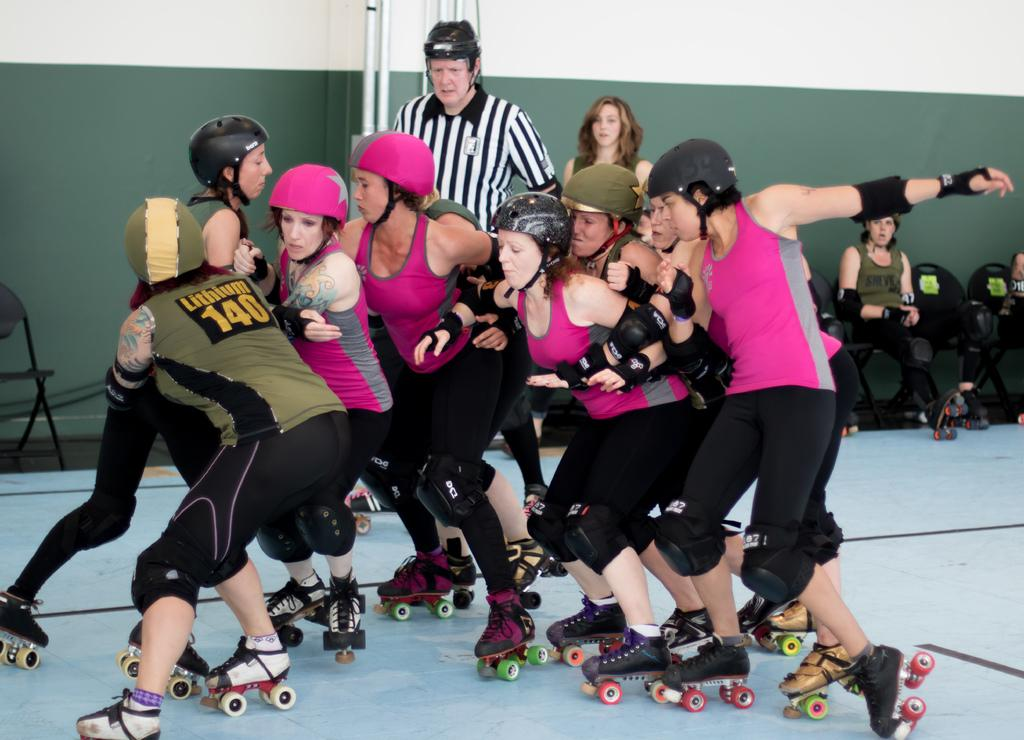<image>
Share a concise interpretation of the image provided. Women are roller skating in a huddle, one woman is wearing the number 140 on her back. 